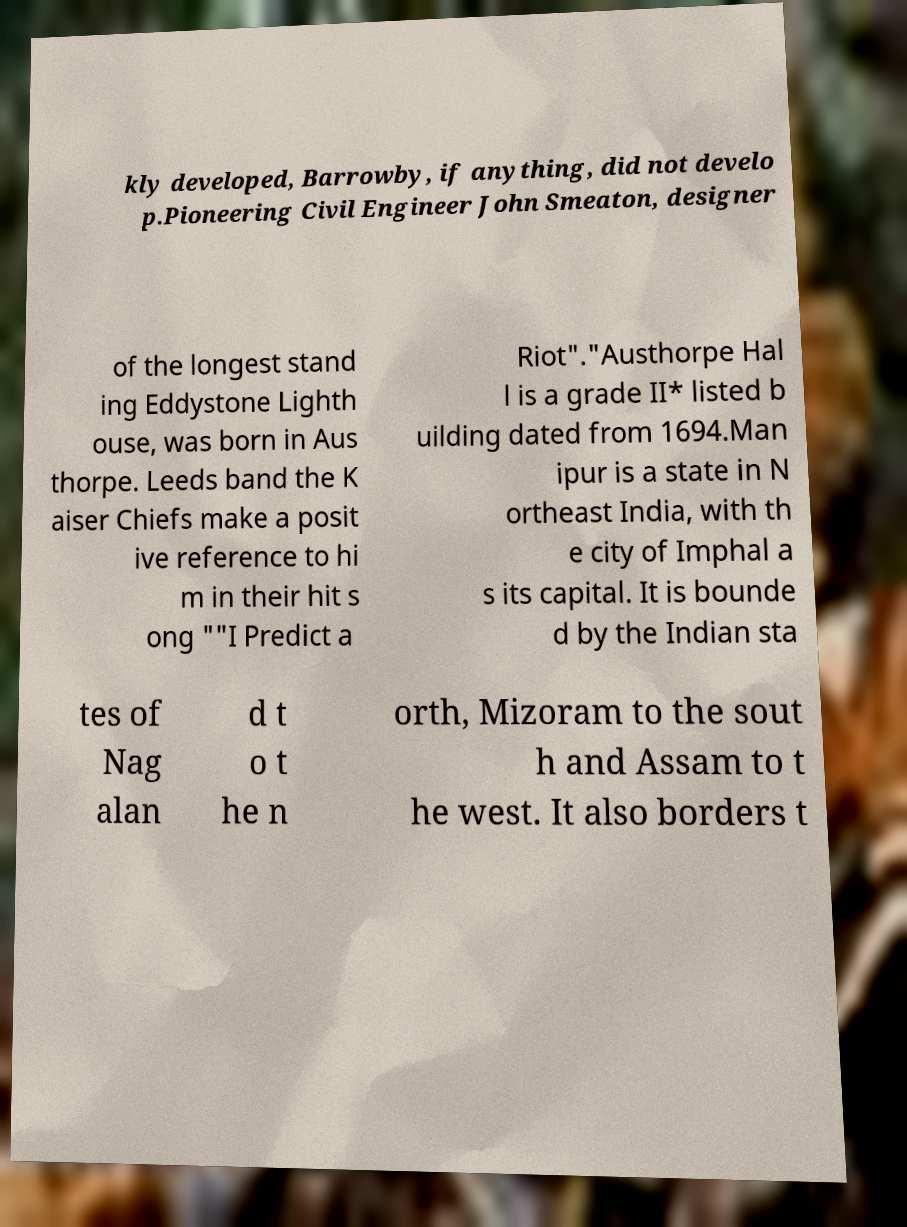There's text embedded in this image that I need extracted. Can you transcribe it verbatim? kly developed, Barrowby, if anything, did not develo p.Pioneering Civil Engineer John Smeaton, designer of the longest stand ing Eddystone Lighth ouse, was born in Aus thorpe. Leeds band the K aiser Chiefs make a posit ive reference to hi m in their hit s ong ""I Predict a Riot"."Austhorpe Hal l is a grade II* listed b uilding dated from 1694.Man ipur is a state in N ortheast India, with th e city of Imphal a s its capital. It is bounde d by the Indian sta tes of Nag alan d t o t he n orth, Mizoram to the sout h and Assam to t he west. It also borders t 